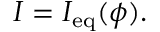<formula> <loc_0><loc_0><loc_500><loc_500>I = I _ { e q } ( \phi ) .</formula> 